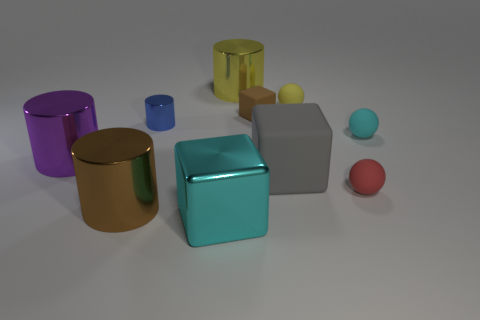Is the number of cyan balls left of the big purple shiny object less than the number of tiny metal objects that are on the right side of the brown shiny object?
Your answer should be compact. Yes. How many large cyan cylinders have the same material as the big cyan block?
Provide a short and direct response. 0. There is a yellow rubber thing; is its size the same as the yellow cylinder that is behind the red rubber ball?
Your answer should be compact. No. There is a thing that is the same color as the metal block; what is its material?
Make the answer very short. Rubber. What size is the brown object to the left of the large metallic thing that is in front of the brown thing that is in front of the brown rubber object?
Your answer should be compact. Large. Is the number of small brown objects that are in front of the small cylinder greater than the number of large cylinders that are to the left of the big brown shiny thing?
Your response must be concise. No. There is a yellow thing in front of the big yellow cylinder; how many small metal things are right of it?
Give a very brief answer. 0. Are there any tiny metal things of the same color as the tiny cylinder?
Ensure brevity in your answer.  No. Does the yellow matte sphere have the same size as the blue object?
Ensure brevity in your answer.  Yes. Do the small cube and the big matte thing have the same color?
Offer a terse response. No. 